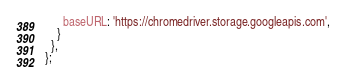<code> <loc_0><loc_0><loc_500><loc_500><_JavaScript_>      baseURL: 'https://chromedriver.storage.googleapis.com',
    }
  },
};
</code> 